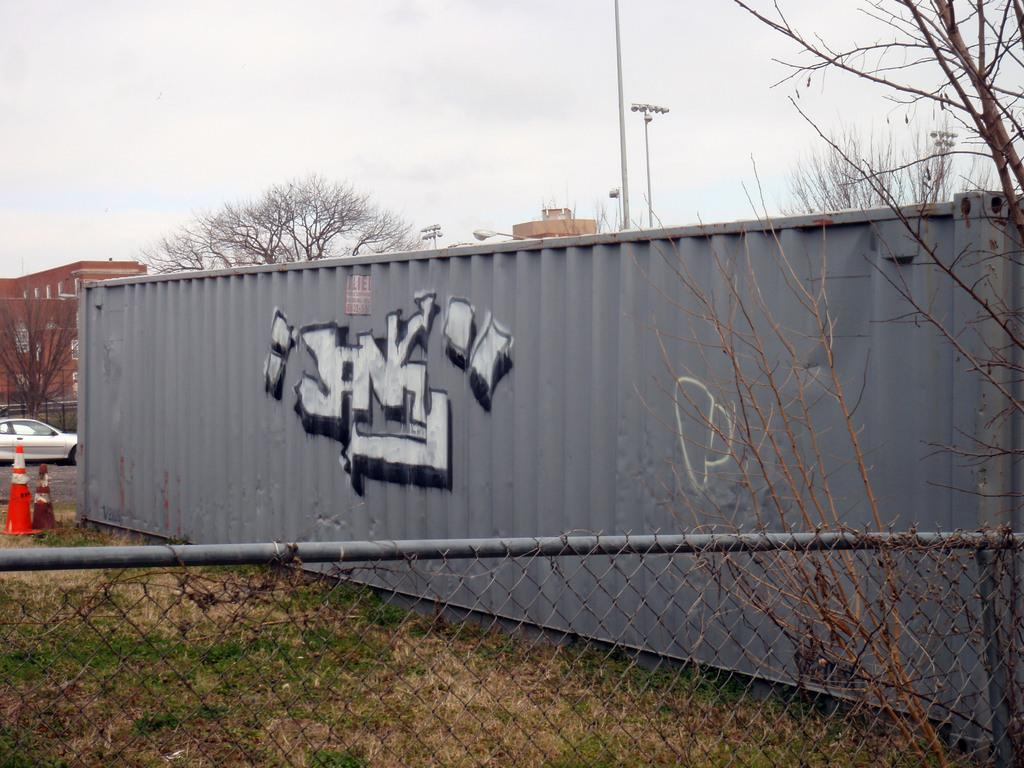<image>
Render a clear and concise summary of the photo. A grey shipping container has graffiti on the side that says Jank. 